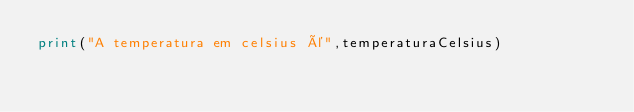Convert code to text. <code><loc_0><loc_0><loc_500><loc_500><_Python_>print("A temperatura em celsius é",temperaturaCelsius)</code> 